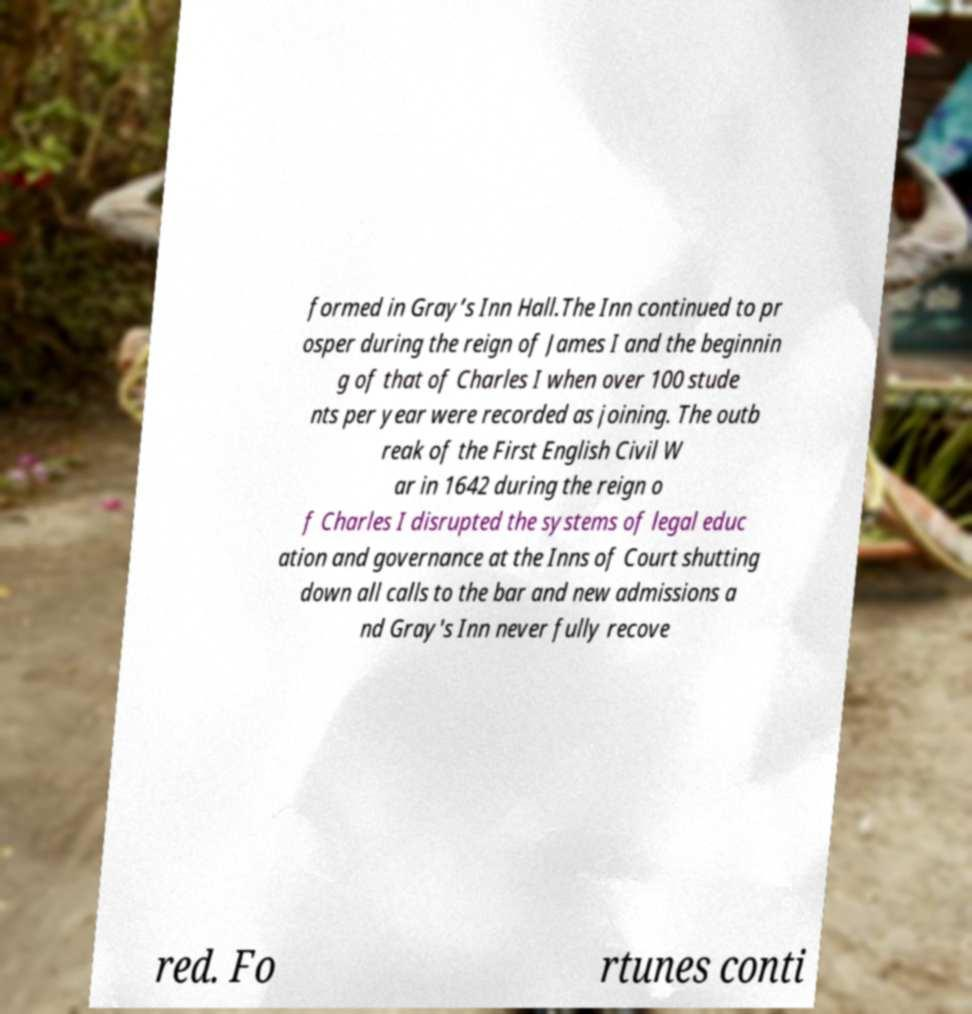Please identify and transcribe the text found in this image. formed in Gray’s Inn Hall.The Inn continued to pr osper during the reign of James I and the beginnin g of that of Charles I when over 100 stude nts per year were recorded as joining. The outb reak of the First English Civil W ar in 1642 during the reign o f Charles I disrupted the systems of legal educ ation and governance at the Inns of Court shutting down all calls to the bar and new admissions a nd Gray's Inn never fully recove red. Fo rtunes conti 